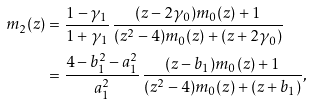<formula> <loc_0><loc_0><loc_500><loc_500>m _ { 2 } ( z ) & = \frac { 1 - \gamma _ { 1 } } { 1 + \gamma _ { 1 } } \, \frac { ( z - 2 \gamma _ { 0 } ) m _ { 0 } ( z ) + 1 } { ( z ^ { 2 } - 4 ) m _ { 0 } ( z ) + ( z + 2 \gamma _ { 0 } ) } \\ & = \frac { 4 - b _ { 1 } ^ { 2 } - a _ { 1 } ^ { 2 } } { a _ { 1 } ^ { 2 } } \, \frac { ( z - b _ { 1 } ) m _ { 0 } ( z ) + 1 } { ( z ^ { 2 } - 4 ) m _ { 0 } ( z ) + ( z + b _ { 1 } ) } ,</formula> 